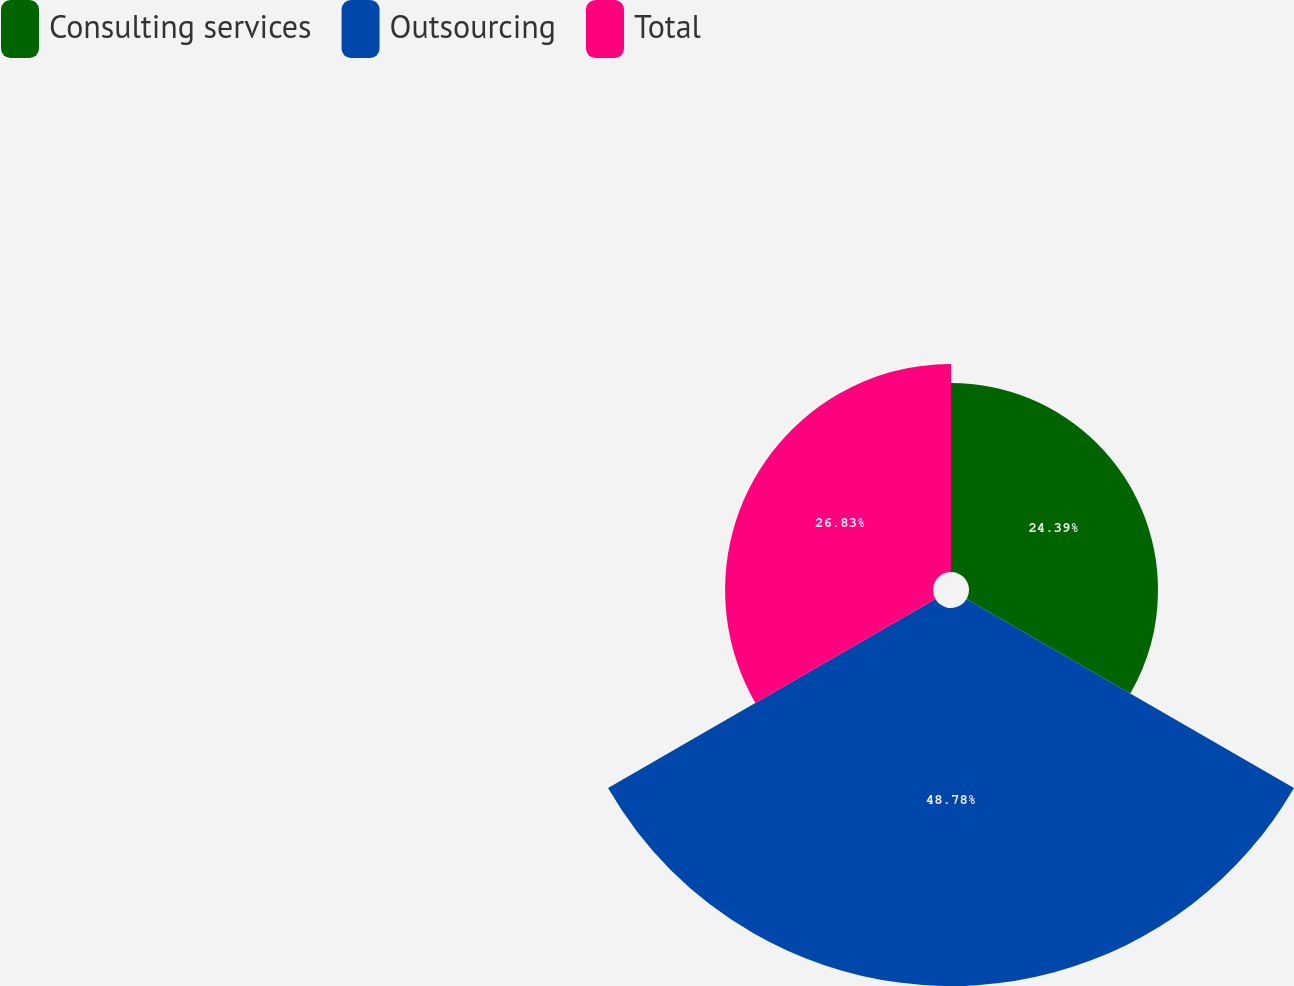Convert chart to OTSL. <chart><loc_0><loc_0><loc_500><loc_500><pie_chart><fcel>Consulting services<fcel>Outsourcing<fcel>Total<nl><fcel>24.39%<fcel>48.78%<fcel>26.83%<nl></chart> 